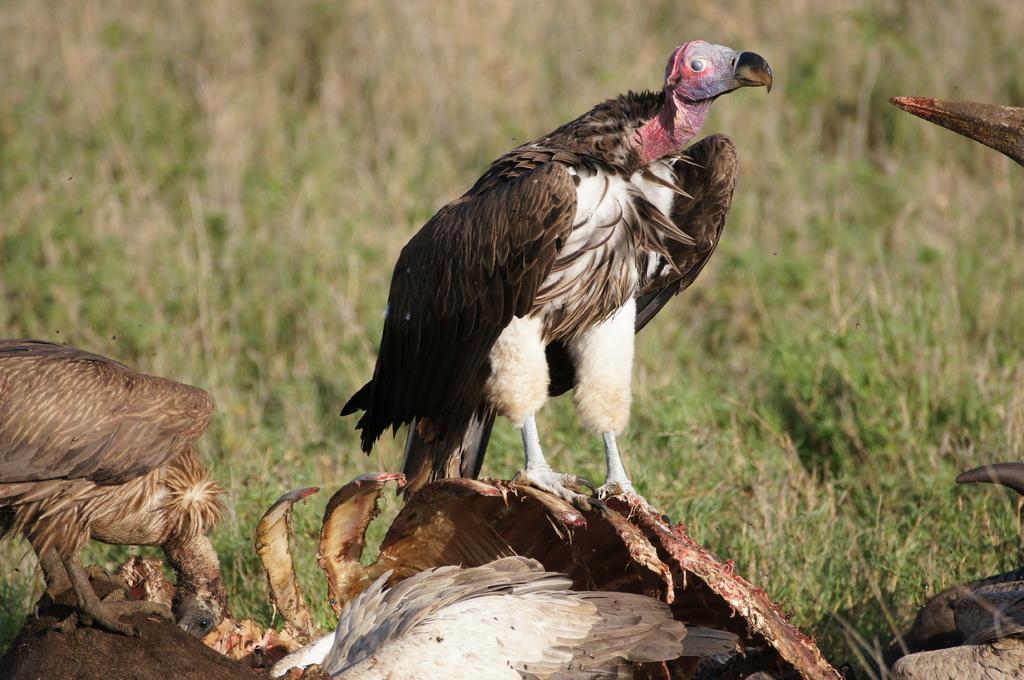Could you give a brief overview of what you see in this image? In this image, there are a few birds. We can see the ground with some objects. We can also see some grass and some objects on the right. 